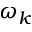Convert formula to latex. <formula><loc_0><loc_0><loc_500><loc_500>\omega _ { k }</formula> 